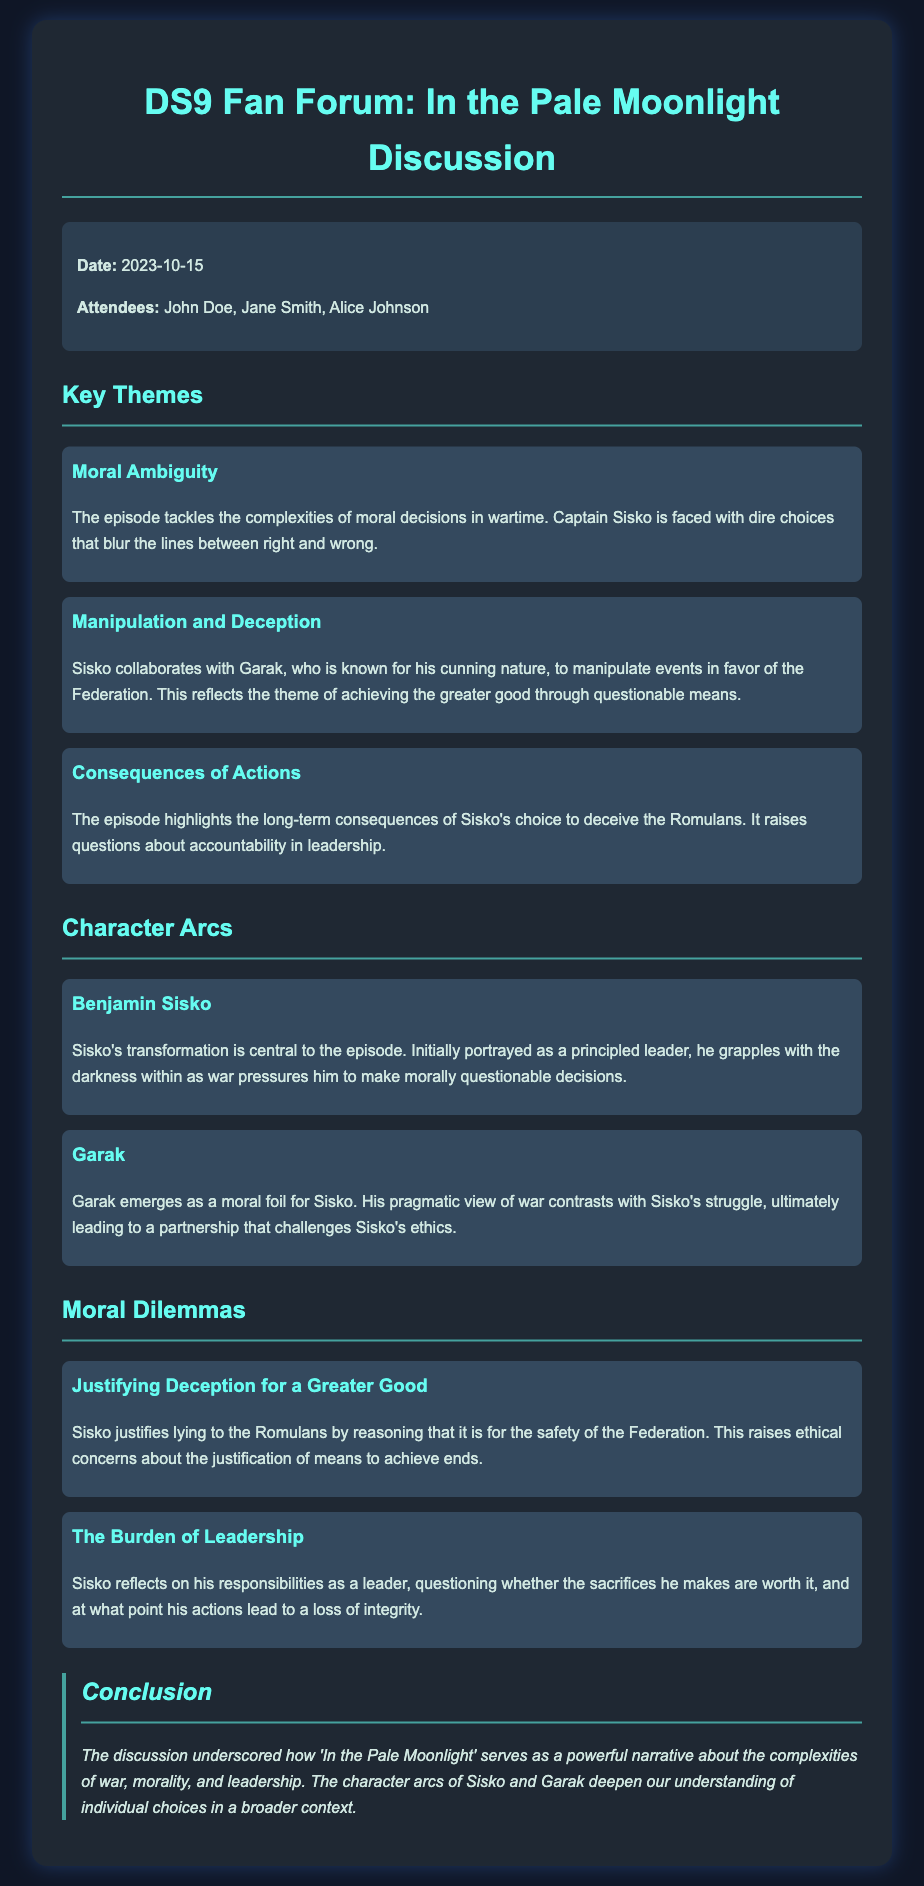What is the date of the meeting? The date is mentioned as the day of discussion in the information section of the document.
Answer: 2023-10-15 Who are the attendees listed in the document? The attendees are named in the information section, which provides the names of participants in the discussion.
Answer: John Doe, Jane Smith, Alice Johnson What is a key theme addressed in the episode? The themes are listed in the document; "Moral Ambiguity" is one such theme discussed.
Answer: Moral Ambiguity How does Garak's perspective contrast with Sisko's? The character arcs section outlines how Garak's view differs from Sisko's, contributing to a deeper narrative.
Answer: Pragmatic What moral dilemma is associated with Sisko's actions? The moral dilemmas are clearly enumerated, detailing the ethical issues involved in Sisko's choices.
Answer: Justifying Deception for a Greater Good What does Sisko reflect on regarding his leadership? Sisko's burdens and reflections regarding leadership are explored in the dilemmas section, highlighting his internal conflicts.
Answer: The Burden of Leadership What is the color scheme used for the headings? The document structure includes styled headings which can be identified from the design details.
Answer: #66fcf1 What narrative aspect does the conclusion emphasize about the episode? The conclusion provides a summary of the main themes discussed, highlighting key narrative elements.
Answer: Complexities of war, morality, and leadership 